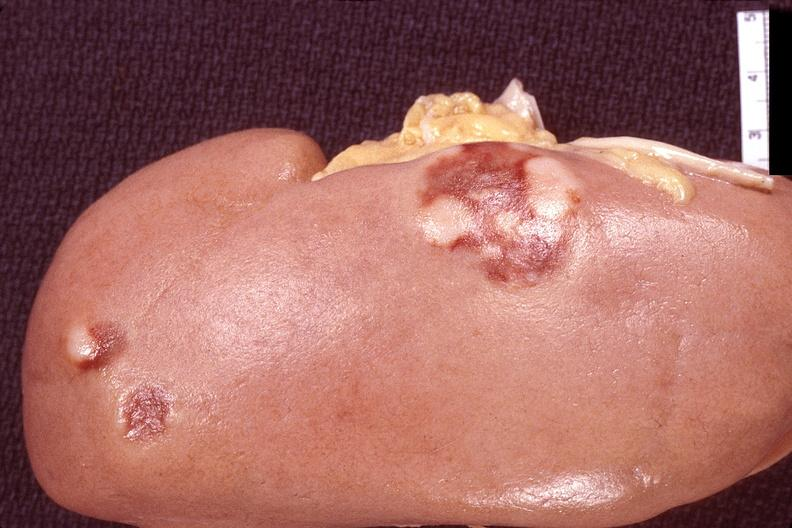does anaplastic astrocytoma show kidney, lymphoma?
Answer the question using a single word or phrase. No 